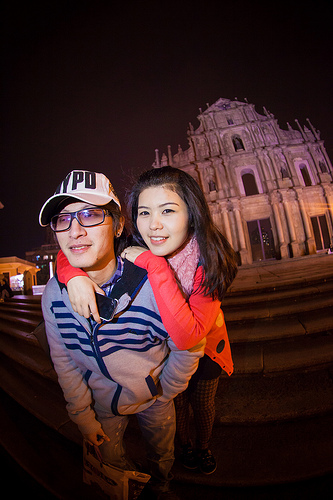<image>
Is there a bag on the woman? No. The bag is not positioned on the woman. They may be near each other, but the bag is not supported by or resting on top of the woman. Is there a man under the cap? Yes. The man is positioned underneath the cap, with the cap above it in the vertical space. Where is the building in relation to the girl? Is it to the right of the girl? No. The building is not to the right of the girl. The horizontal positioning shows a different relationship. 